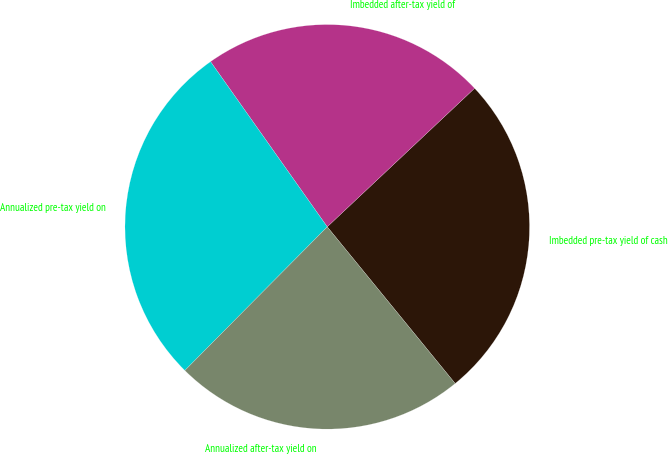<chart> <loc_0><loc_0><loc_500><loc_500><pie_chart><fcel>Imbedded pre-tax yield of cash<fcel>Imbedded after-tax yield of<fcel>Annualized pre-tax yield on<fcel>Annualized after-tax yield on<nl><fcel>26.11%<fcel>22.78%<fcel>27.78%<fcel>23.33%<nl></chart> 